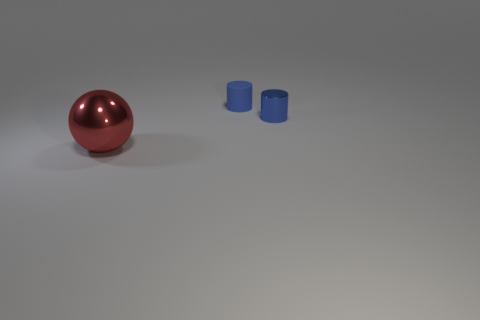Subtract all spheres. How many objects are left? 2 Add 3 large red metal objects. How many objects exist? 6 Subtract 0 green cylinders. How many objects are left? 3 Subtract all cyan cylinders. Subtract all purple spheres. How many cylinders are left? 2 Subtract all red balls. Subtract all cyan shiny objects. How many objects are left? 2 Add 2 small things. How many small things are left? 4 Add 2 large balls. How many large balls exist? 3 